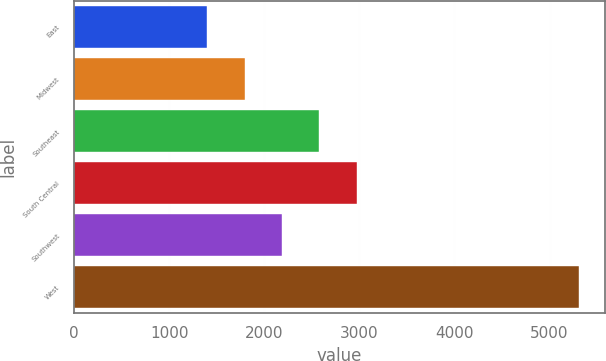<chart> <loc_0><loc_0><loc_500><loc_500><bar_chart><fcel>East<fcel>Midwest<fcel>Southeast<fcel>South Central<fcel>Southwest<fcel>West<nl><fcel>1393.9<fcel>1795.7<fcel>2579.6<fcel>2971.55<fcel>2187.65<fcel>5313.4<nl></chart> 